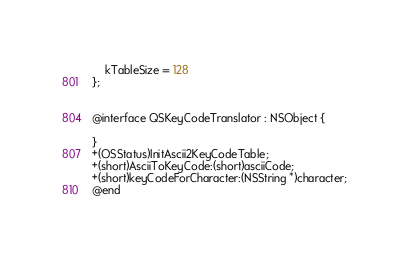<code> <loc_0><loc_0><loc_500><loc_500><_C_>    kTableSize = 128
};


@interface QSKeyCodeTranslator : NSObject {

}
+(OSStatus)InitAscii2KeyCodeTable;
+(short)AsciiToKeyCode:(short)asciiCode;
+(short)keyCodeForCharacter:(NSString *)character;
@end
</code> 